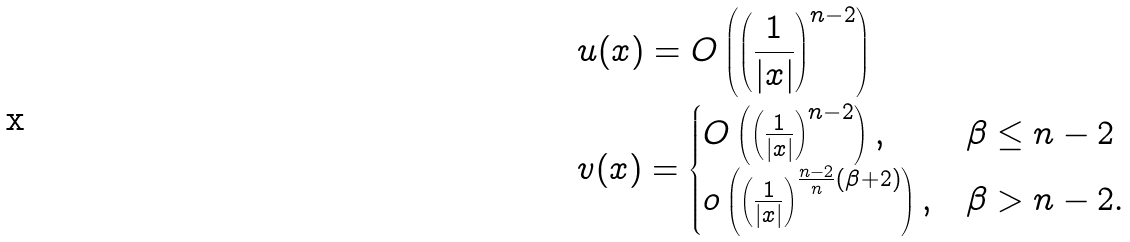<formula> <loc_0><loc_0><loc_500><loc_500>& u ( x ) = O \left ( \left ( \frac { 1 } { | x | } \right ) ^ { n - 2 } \right ) \\ & v ( x ) = \begin{cases} O \left ( \left ( \frac { 1 } { | x | } \right ) ^ { n - 2 } \right ) , & \beta \leq n - 2 \\ o \left ( \left ( \frac { 1 } { | x | } \right ) ^ { \frac { n - 2 } { n } ( \beta + 2 ) } \right ) , & \beta > n - 2 . \end{cases}</formula> 